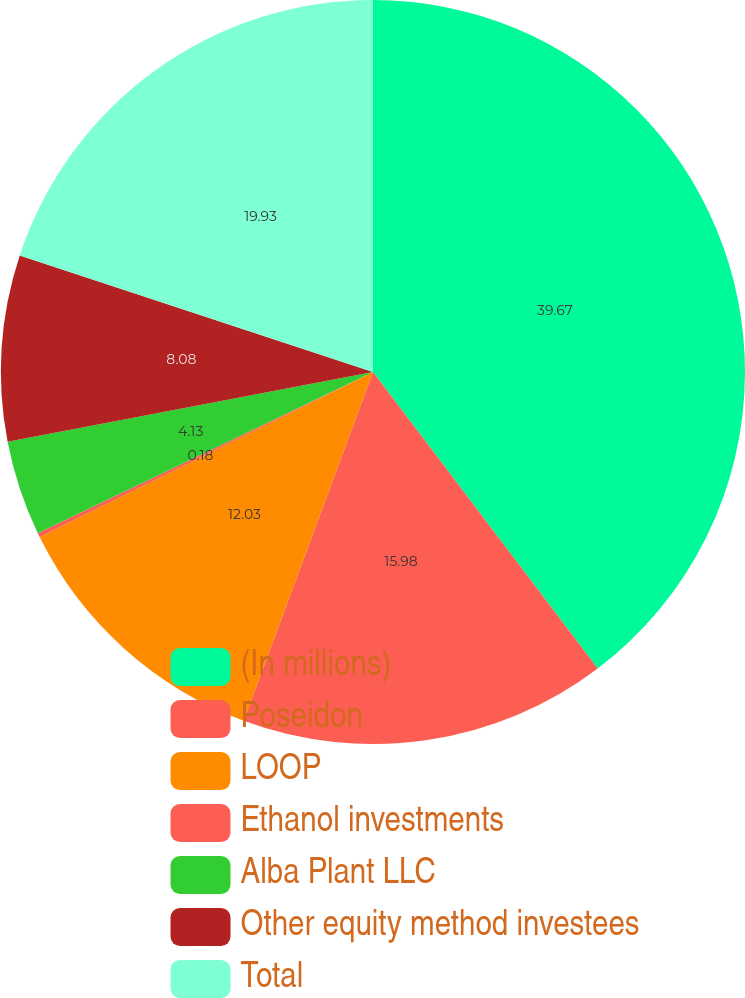Convert chart to OTSL. <chart><loc_0><loc_0><loc_500><loc_500><pie_chart><fcel>(In millions)<fcel>Poseidon<fcel>LOOP<fcel>Ethanol investments<fcel>Alba Plant LLC<fcel>Other equity method investees<fcel>Total<nl><fcel>39.68%<fcel>15.98%<fcel>12.03%<fcel>0.18%<fcel>4.13%<fcel>8.08%<fcel>19.93%<nl></chart> 